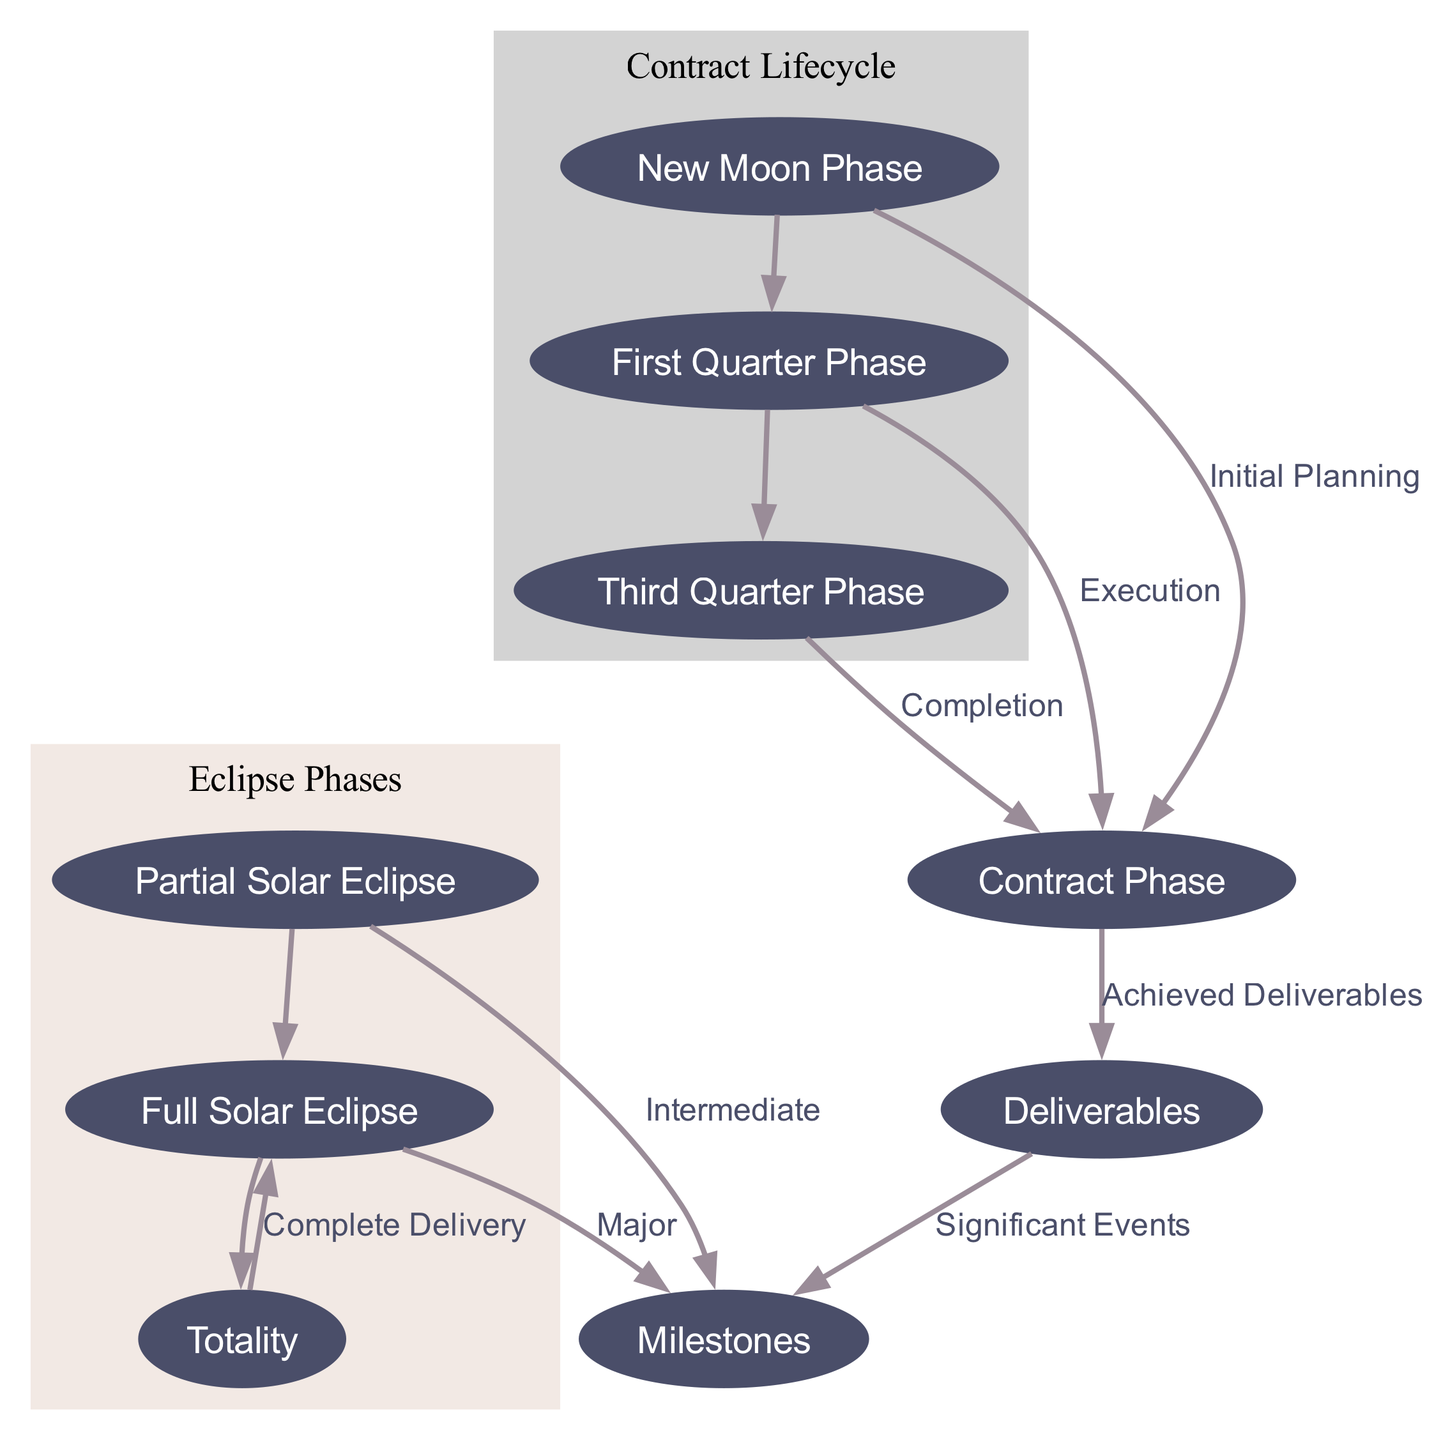What are the key stages of the contract lifecycle? The diagram shows the node labeled “Contract Phase,” which encompasses the key stages within the contract lifecycle, linking through first quarter and third quarter phases.
Answer: Contract Phase How many nodes are present in the diagram? By counting the individual entries listed under 'nodes', we find there are 9 unique nodes in the diagram.
Answer: 9 Which node represents intermediate milestones? The node labeled “Partial Solar Eclipse” indicates the intermediate milestones in the project lifecycle according to the diagram.
Answer: Partial Solar Eclipse What phase follows the Execution phase in the contract lifecycle? The diagram shows an edge leading from the “First Quarter Phase” to the “Third Quarter Phase,” indicating that the Third Quarter Phase follows.
Answer: Third Quarter Phase What is the relationship between Milestones and Deliverables? The diagram includes an edge that connects "Deliverables" to "Milestones," denoting significant events that derive from the achieved deliverables.
Answer: Significant Events What indicates major milestones in the diagram? The node labeled “Full Solar Eclipse” signifies the major milestones as illustrated, demonstrating clear delivery completions.
Answer: Full Solar Eclipse What is represented by the Totality node? The diagram specifies “Totality” as the point of contract completion and review, showing its significance in the overview of phases.
Answer: Complete Delivery How are the phases of a solar eclipse represented in relation to contract milestones? The diagram organizes phases of a solar eclipse, such as "Partial Eclipse" and "Full Eclipse," to align with the stages of achieving contract milestones, illustrating an analogy between eclipse occurrences and deliverables.
Answer: Eclipse Phases What color is used for the nodes in the Contract Lifecycle cluster? The nodes in the Contract Lifecycle cluster are styled with a light grey background color according to the diagram.
Answer: Light Grey 